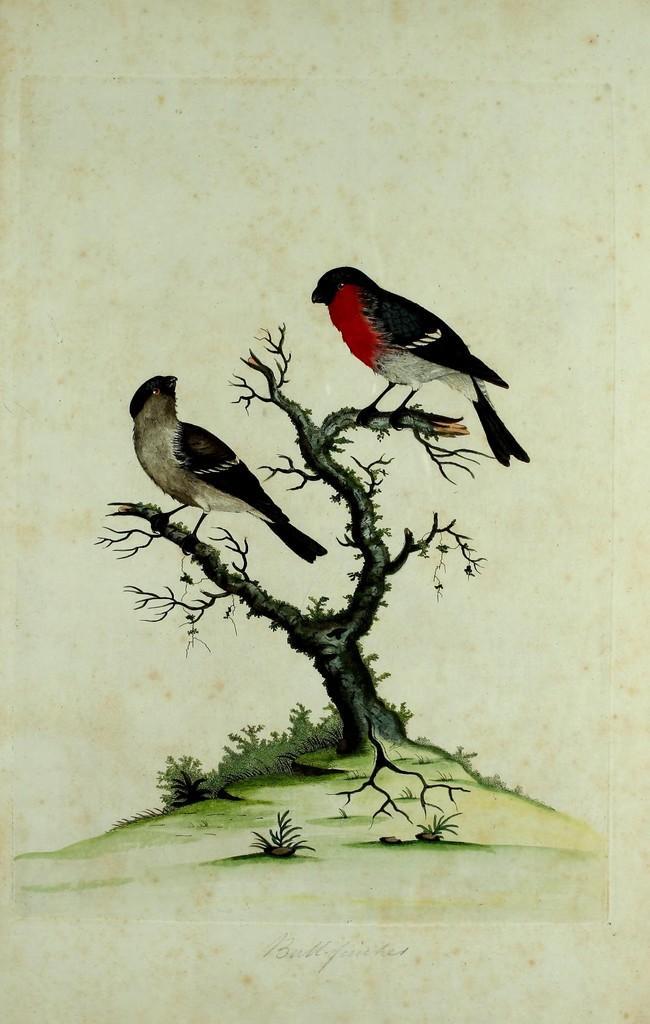In one or two sentences, can you explain what this image depicts? In this image I see a paper on which there is an art of a tree on which there are 2 birds and I see plants on the ground. 